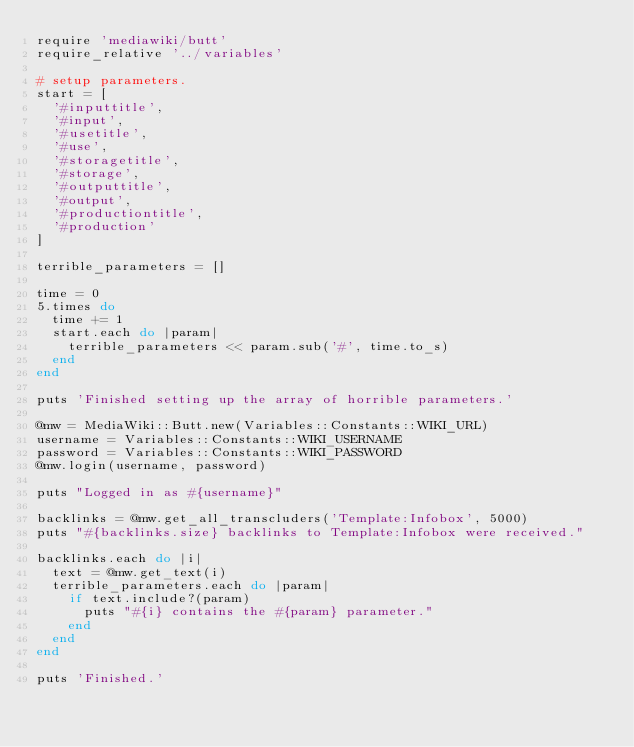Convert code to text. <code><loc_0><loc_0><loc_500><loc_500><_Ruby_>require 'mediawiki/butt'
require_relative '../variables'

# setup parameters.
start = [
  '#inputtitle',
  '#input',
  '#usetitle',
  '#use',
  '#storagetitle',
  '#storage',
  '#outputtitle',
  '#output',
  '#productiontitle',
  '#production'
]

terrible_parameters = []

time = 0
5.times do
  time += 1
  start.each do |param|
    terrible_parameters << param.sub('#', time.to_s)
  end
end

puts 'Finished setting up the array of horrible parameters.'

@mw = MediaWiki::Butt.new(Variables::Constants::WIKI_URL)
username = Variables::Constants::WIKI_USERNAME
password = Variables::Constants::WIKI_PASSWORD
@mw.login(username, password)

puts "Logged in as #{username}"

backlinks = @mw.get_all_transcluders('Template:Infobox', 5000)
puts "#{backlinks.size} backlinks to Template:Infobox were received."

backlinks.each do |i|
  text = @mw.get_text(i)
  terrible_parameters.each do |param|
    if text.include?(param)
      puts "#{i} contains the #{param} parameter."
    end
  end
end

puts 'Finished.'</code> 